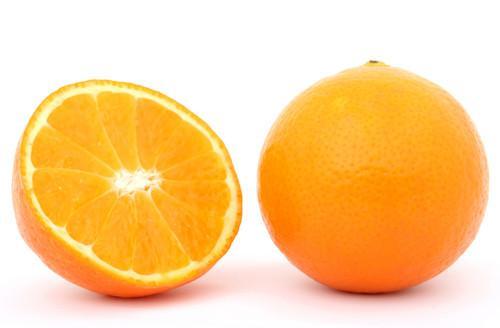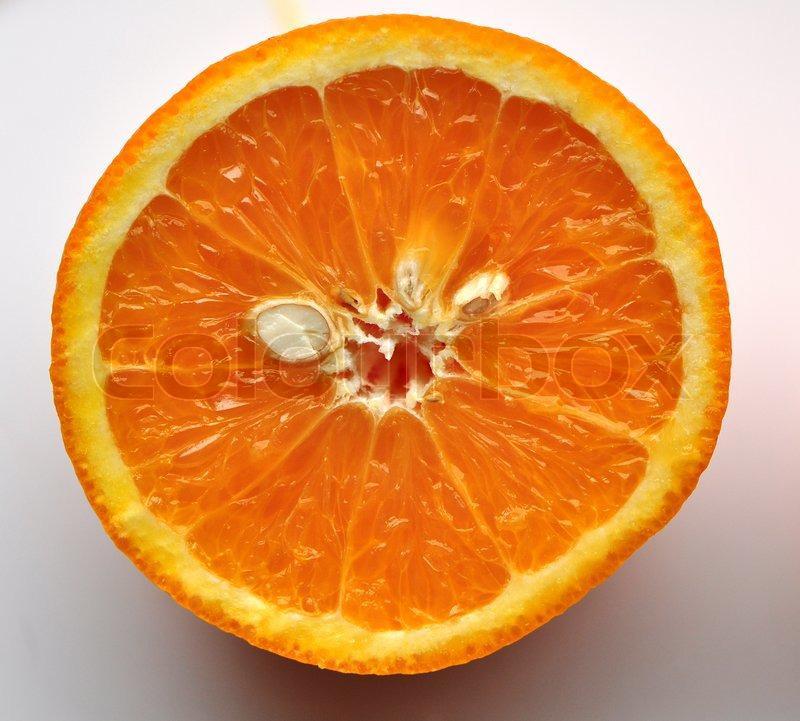The first image is the image on the left, the second image is the image on the right. Assess this claim about the two images: "There is a whole citrus fruit in one of the images.". Correct or not? Answer yes or no. Yes. 